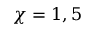Convert formula to latex. <formula><loc_0><loc_0><loc_500><loc_500>\chi = 1 , 5</formula> 